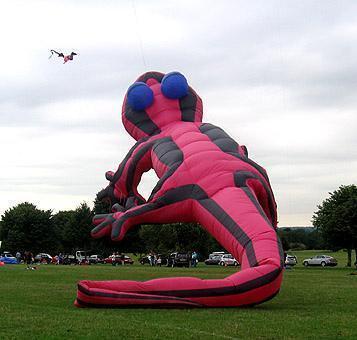What reptile is depicted in the extra large kite?
From the following set of four choices, select the accurate answer to respond to the question.
Options: Chameleon, iguana, tortoise, lizard. Chameleon. 